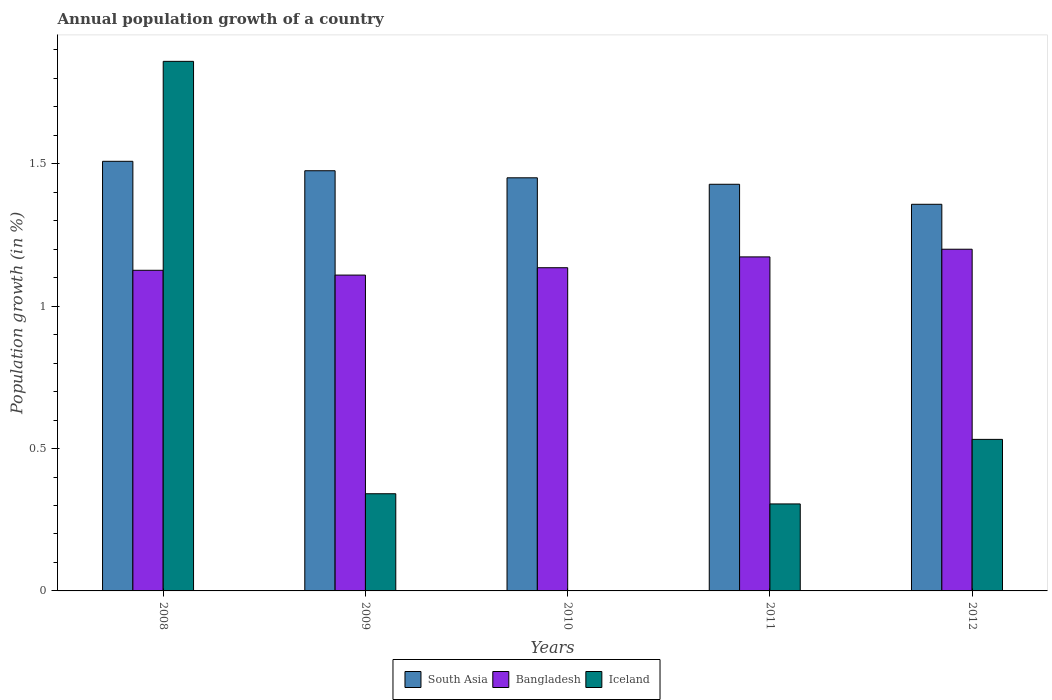How many different coloured bars are there?
Keep it short and to the point. 3. How many bars are there on the 1st tick from the left?
Offer a very short reply. 3. How many bars are there on the 1st tick from the right?
Your response must be concise. 3. What is the label of the 1st group of bars from the left?
Give a very brief answer. 2008. What is the annual population growth in Bangladesh in 2010?
Your answer should be very brief. 1.13. Across all years, what is the maximum annual population growth in Iceland?
Provide a succinct answer. 1.86. Across all years, what is the minimum annual population growth in South Asia?
Make the answer very short. 1.36. In which year was the annual population growth in Iceland maximum?
Ensure brevity in your answer.  2008. What is the total annual population growth in Iceland in the graph?
Make the answer very short. 3.04. What is the difference between the annual population growth in Iceland in 2008 and that in 2011?
Give a very brief answer. 1.55. What is the difference between the annual population growth in Bangladesh in 2010 and the annual population growth in South Asia in 2009?
Make the answer very short. -0.34. What is the average annual population growth in South Asia per year?
Ensure brevity in your answer.  1.44. In the year 2010, what is the difference between the annual population growth in Bangladesh and annual population growth in South Asia?
Offer a very short reply. -0.32. In how many years, is the annual population growth in Bangladesh greater than 1.1 %?
Give a very brief answer. 5. What is the ratio of the annual population growth in Bangladesh in 2008 to that in 2012?
Make the answer very short. 0.94. Is the annual population growth in South Asia in 2009 less than that in 2011?
Your response must be concise. No. What is the difference between the highest and the second highest annual population growth in Iceland?
Your answer should be very brief. 1.33. What is the difference between the highest and the lowest annual population growth in Bangladesh?
Ensure brevity in your answer.  0.09. Is the sum of the annual population growth in South Asia in 2008 and 2011 greater than the maximum annual population growth in Iceland across all years?
Keep it short and to the point. Yes. Is it the case that in every year, the sum of the annual population growth in Bangladesh and annual population growth in South Asia is greater than the annual population growth in Iceland?
Provide a succinct answer. Yes. Are all the bars in the graph horizontal?
Your answer should be very brief. No. How many years are there in the graph?
Provide a short and direct response. 5. Are the values on the major ticks of Y-axis written in scientific E-notation?
Your answer should be compact. No. Does the graph contain any zero values?
Your response must be concise. Yes. Where does the legend appear in the graph?
Provide a short and direct response. Bottom center. How many legend labels are there?
Your response must be concise. 3. How are the legend labels stacked?
Offer a very short reply. Horizontal. What is the title of the graph?
Your response must be concise. Annual population growth of a country. What is the label or title of the Y-axis?
Your response must be concise. Population growth (in %). What is the Population growth (in %) in South Asia in 2008?
Your response must be concise. 1.51. What is the Population growth (in %) in Bangladesh in 2008?
Provide a short and direct response. 1.13. What is the Population growth (in %) of Iceland in 2008?
Ensure brevity in your answer.  1.86. What is the Population growth (in %) of South Asia in 2009?
Your answer should be very brief. 1.48. What is the Population growth (in %) of Bangladesh in 2009?
Your response must be concise. 1.11. What is the Population growth (in %) of Iceland in 2009?
Provide a short and direct response. 0.34. What is the Population growth (in %) of South Asia in 2010?
Offer a terse response. 1.45. What is the Population growth (in %) of Bangladesh in 2010?
Your answer should be very brief. 1.13. What is the Population growth (in %) of Iceland in 2010?
Provide a short and direct response. 0. What is the Population growth (in %) in South Asia in 2011?
Keep it short and to the point. 1.43. What is the Population growth (in %) of Bangladesh in 2011?
Provide a succinct answer. 1.17. What is the Population growth (in %) in Iceland in 2011?
Your answer should be very brief. 0.31. What is the Population growth (in %) in South Asia in 2012?
Ensure brevity in your answer.  1.36. What is the Population growth (in %) in Bangladesh in 2012?
Give a very brief answer. 1.2. What is the Population growth (in %) in Iceland in 2012?
Offer a very short reply. 0.53. Across all years, what is the maximum Population growth (in %) in South Asia?
Provide a succinct answer. 1.51. Across all years, what is the maximum Population growth (in %) of Bangladesh?
Your answer should be compact. 1.2. Across all years, what is the maximum Population growth (in %) of Iceland?
Ensure brevity in your answer.  1.86. Across all years, what is the minimum Population growth (in %) in South Asia?
Give a very brief answer. 1.36. Across all years, what is the minimum Population growth (in %) of Bangladesh?
Offer a very short reply. 1.11. What is the total Population growth (in %) of South Asia in the graph?
Your answer should be compact. 7.22. What is the total Population growth (in %) in Bangladesh in the graph?
Keep it short and to the point. 5.74. What is the total Population growth (in %) in Iceland in the graph?
Keep it short and to the point. 3.04. What is the difference between the Population growth (in %) of South Asia in 2008 and that in 2009?
Ensure brevity in your answer.  0.03. What is the difference between the Population growth (in %) in Bangladesh in 2008 and that in 2009?
Provide a short and direct response. 0.02. What is the difference between the Population growth (in %) in Iceland in 2008 and that in 2009?
Make the answer very short. 1.52. What is the difference between the Population growth (in %) of South Asia in 2008 and that in 2010?
Offer a terse response. 0.06. What is the difference between the Population growth (in %) in Bangladesh in 2008 and that in 2010?
Your answer should be compact. -0.01. What is the difference between the Population growth (in %) in South Asia in 2008 and that in 2011?
Offer a terse response. 0.08. What is the difference between the Population growth (in %) in Bangladesh in 2008 and that in 2011?
Keep it short and to the point. -0.05. What is the difference between the Population growth (in %) of Iceland in 2008 and that in 2011?
Ensure brevity in your answer.  1.55. What is the difference between the Population growth (in %) in South Asia in 2008 and that in 2012?
Make the answer very short. 0.15. What is the difference between the Population growth (in %) in Bangladesh in 2008 and that in 2012?
Provide a short and direct response. -0.07. What is the difference between the Population growth (in %) of Iceland in 2008 and that in 2012?
Offer a terse response. 1.33. What is the difference between the Population growth (in %) of South Asia in 2009 and that in 2010?
Offer a very short reply. 0.02. What is the difference between the Population growth (in %) in Bangladesh in 2009 and that in 2010?
Give a very brief answer. -0.03. What is the difference between the Population growth (in %) of South Asia in 2009 and that in 2011?
Offer a terse response. 0.05. What is the difference between the Population growth (in %) in Bangladesh in 2009 and that in 2011?
Make the answer very short. -0.06. What is the difference between the Population growth (in %) in Iceland in 2009 and that in 2011?
Your answer should be very brief. 0.04. What is the difference between the Population growth (in %) in South Asia in 2009 and that in 2012?
Your answer should be very brief. 0.12. What is the difference between the Population growth (in %) in Bangladesh in 2009 and that in 2012?
Your response must be concise. -0.09. What is the difference between the Population growth (in %) of Iceland in 2009 and that in 2012?
Offer a terse response. -0.19. What is the difference between the Population growth (in %) of South Asia in 2010 and that in 2011?
Give a very brief answer. 0.02. What is the difference between the Population growth (in %) of Bangladesh in 2010 and that in 2011?
Provide a short and direct response. -0.04. What is the difference between the Population growth (in %) of South Asia in 2010 and that in 2012?
Offer a very short reply. 0.09. What is the difference between the Population growth (in %) in Bangladesh in 2010 and that in 2012?
Provide a short and direct response. -0.07. What is the difference between the Population growth (in %) in South Asia in 2011 and that in 2012?
Make the answer very short. 0.07. What is the difference between the Population growth (in %) in Bangladesh in 2011 and that in 2012?
Provide a short and direct response. -0.03. What is the difference between the Population growth (in %) in Iceland in 2011 and that in 2012?
Give a very brief answer. -0.23. What is the difference between the Population growth (in %) in South Asia in 2008 and the Population growth (in %) in Bangladesh in 2009?
Offer a terse response. 0.4. What is the difference between the Population growth (in %) in South Asia in 2008 and the Population growth (in %) in Iceland in 2009?
Keep it short and to the point. 1.17. What is the difference between the Population growth (in %) in Bangladesh in 2008 and the Population growth (in %) in Iceland in 2009?
Keep it short and to the point. 0.78. What is the difference between the Population growth (in %) in South Asia in 2008 and the Population growth (in %) in Bangladesh in 2010?
Ensure brevity in your answer.  0.37. What is the difference between the Population growth (in %) in South Asia in 2008 and the Population growth (in %) in Bangladesh in 2011?
Provide a short and direct response. 0.34. What is the difference between the Population growth (in %) of South Asia in 2008 and the Population growth (in %) of Iceland in 2011?
Offer a very short reply. 1.2. What is the difference between the Population growth (in %) in Bangladesh in 2008 and the Population growth (in %) in Iceland in 2011?
Your answer should be compact. 0.82. What is the difference between the Population growth (in %) in South Asia in 2008 and the Population growth (in %) in Bangladesh in 2012?
Your answer should be very brief. 0.31. What is the difference between the Population growth (in %) in South Asia in 2008 and the Population growth (in %) in Iceland in 2012?
Provide a short and direct response. 0.98. What is the difference between the Population growth (in %) of Bangladesh in 2008 and the Population growth (in %) of Iceland in 2012?
Make the answer very short. 0.59. What is the difference between the Population growth (in %) in South Asia in 2009 and the Population growth (in %) in Bangladesh in 2010?
Give a very brief answer. 0.34. What is the difference between the Population growth (in %) of South Asia in 2009 and the Population growth (in %) of Bangladesh in 2011?
Your answer should be compact. 0.3. What is the difference between the Population growth (in %) in South Asia in 2009 and the Population growth (in %) in Iceland in 2011?
Your answer should be very brief. 1.17. What is the difference between the Population growth (in %) in Bangladesh in 2009 and the Population growth (in %) in Iceland in 2011?
Your answer should be compact. 0.8. What is the difference between the Population growth (in %) of South Asia in 2009 and the Population growth (in %) of Bangladesh in 2012?
Your answer should be compact. 0.28. What is the difference between the Population growth (in %) of South Asia in 2009 and the Population growth (in %) of Iceland in 2012?
Your response must be concise. 0.94. What is the difference between the Population growth (in %) in Bangladesh in 2009 and the Population growth (in %) in Iceland in 2012?
Make the answer very short. 0.58. What is the difference between the Population growth (in %) in South Asia in 2010 and the Population growth (in %) in Bangladesh in 2011?
Your answer should be very brief. 0.28. What is the difference between the Population growth (in %) of South Asia in 2010 and the Population growth (in %) of Iceland in 2011?
Your response must be concise. 1.15. What is the difference between the Population growth (in %) of Bangladesh in 2010 and the Population growth (in %) of Iceland in 2011?
Offer a very short reply. 0.83. What is the difference between the Population growth (in %) in South Asia in 2010 and the Population growth (in %) in Bangladesh in 2012?
Offer a very short reply. 0.25. What is the difference between the Population growth (in %) of South Asia in 2010 and the Population growth (in %) of Iceland in 2012?
Give a very brief answer. 0.92. What is the difference between the Population growth (in %) in Bangladesh in 2010 and the Population growth (in %) in Iceland in 2012?
Your answer should be very brief. 0.6. What is the difference between the Population growth (in %) in South Asia in 2011 and the Population growth (in %) in Bangladesh in 2012?
Your answer should be compact. 0.23. What is the difference between the Population growth (in %) of South Asia in 2011 and the Population growth (in %) of Iceland in 2012?
Make the answer very short. 0.9. What is the difference between the Population growth (in %) of Bangladesh in 2011 and the Population growth (in %) of Iceland in 2012?
Ensure brevity in your answer.  0.64. What is the average Population growth (in %) in South Asia per year?
Your response must be concise. 1.44. What is the average Population growth (in %) in Bangladesh per year?
Keep it short and to the point. 1.15. What is the average Population growth (in %) of Iceland per year?
Offer a very short reply. 0.61. In the year 2008, what is the difference between the Population growth (in %) of South Asia and Population growth (in %) of Bangladesh?
Your answer should be very brief. 0.38. In the year 2008, what is the difference between the Population growth (in %) in South Asia and Population growth (in %) in Iceland?
Provide a succinct answer. -0.35. In the year 2008, what is the difference between the Population growth (in %) of Bangladesh and Population growth (in %) of Iceland?
Provide a succinct answer. -0.73. In the year 2009, what is the difference between the Population growth (in %) of South Asia and Population growth (in %) of Bangladesh?
Your response must be concise. 0.37. In the year 2009, what is the difference between the Population growth (in %) of South Asia and Population growth (in %) of Iceland?
Keep it short and to the point. 1.13. In the year 2009, what is the difference between the Population growth (in %) in Bangladesh and Population growth (in %) in Iceland?
Give a very brief answer. 0.77. In the year 2010, what is the difference between the Population growth (in %) of South Asia and Population growth (in %) of Bangladesh?
Make the answer very short. 0.32. In the year 2011, what is the difference between the Population growth (in %) of South Asia and Population growth (in %) of Bangladesh?
Give a very brief answer. 0.26. In the year 2011, what is the difference between the Population growth (in %) of South Asia and Population growth (in %) of Iceland?
Give a very brief answer. 1.12. In the year 2011, what is the difference between the Population growth (in %) of Bangladesh and Population growth (in %) of Iceland?
Keep it short and to the point. 0.87. In the year 2012, what is the difference between the Population growth (in %) in South Asia and Population growth (in %) in Bangladesh?
Keep it short and to the point. 0.16. In the year 2012, what is the difference between the Population growth (in %) of South Asia and Population growth (in %) of Iceland?
Your response must be concise. 0.83. In the year 2012, what is the difference between the Population growth (in %) in Bangladesh and Population growth (in %) in Iceland?
Make the answer very short. 0.67. What is the ratio of the Population growth (in %) of South Asia in 2008 to that in 2009?
Give a very brief answer. 1.02. What is the ratio of the Population growth (in %) of Bangladesh in 2008 to that in 2009?
Provide a succinct answer. 1.02. What is the ratio of the Population growth (in %) of Iceland in 2008 to that in 2009?
Provide a succinct answer. 5.45. What is the ratio of the Population growth (in %) of South Asia in 2008 to that in 2010?
Provide a succinct answer. 1.04. What is the ratio of the Population growth (in %) of South Asia in 2008 to that in 2011?
Offer a very short reply. 1.06. What is the ratio of the Population growth (in %) in Bangladesh in 2008 to that in 2011?
Offer a very short reply. 0.96. What is the ratio of the Population growth (in %) in Iceland in 2008 to that in 2011?
Provide a short and direct response. 6.09. What is the ratio of the Population growth (in %) of South Asia in 2008 to that in 2012?
Give a very brief answer. 1.11. What is the ratio of the Population growth (in %) in Bangladesh in 2008 to that in 2012?
Make the answer very short. 0.94. What is the ratio of the Population growth (in %) in Iceland in 2008 to that in 2012?
Offer a very short reply. 3.49. What is the ratio of the Population growth (in %) in South Asia in 2009 to that in 2010?
Your response must be concise. 1.02. What is the ratio of the Population growth (in %) in Bangladesh in 2009 to that in 2010?
Give a very brief answer. 0.98. What is the ratio of the Population growth (in %) in Bangladesh in 2009 to that in 2011?
Keep it short and to the point. 0.95. What is the ratio of the Population growth (in %) of Iceland in 2009 to that in 2011?
Provide a short and direct response. 1.12. What is the ratio of the Population growth (in %) of South Asia in 2009 to that in 2012?
Offer a terse response. 1.09. What is the ratio of the Population growth (in %) of Bangladesh in 2009 to that in 2012?
Offer a terse response. 0.92. What is the ratio of the Population growth (in %) in Iceland in 2009 to that in 2012?
Your response must be concise. 0.64. What is the ratio of the Population growth (in %) of South Asia in 2010 to that in 2011?
Your response must be concise. 1.02. What is the ratio of the Population growth (in %) of Bangladesh in 2010 to that in 2011?
Keep it short and to the point. 0.97. What is the ratio of the Population growth (in %) of South Asia in 2010 to that in 2012?
Your answer should be very brief. 1.07. What is the ratio of the Population growth (in %) of Bangladesh in 2010 to that in 2012?
Ensure brevity in your answer.  0.95. What is the ratio of the Population growth (in %) of South Asia in 2011 to that in 2012?
Make the answer very short. 1.05. What is the ratio of the Population growth (in %) in Bangladesh in 2011 to that in 2012?
Offer a terse response. 0.98. What is the ratio of the Population growth (in %) of Iceland in 2011 to that in 2012?
Keep it short and to the point. 0.57. What is the difference between the highest and the second highest Population growth (in %) in South Asia?
Offer a very short reply. 0.03. What is the difference between the highest and the second highest Population growth (in %) in Bangladesh?
Offer a terse response. 0.03. What is the difference between the highest and the second highest Population growth (in %) of Iceland?
Make the answer very short. 1.33. What is the difference between the highest and the lowest Population growth (in %) of South Asia?
Make the answer very short. 0.15. What is the difference between the highest and the lowest Population growth (in %) in Bangladesh?
Provide a succinct answer. 0.09. What is the difference between the highest and the lowest Population growth (in %) in Iceland?
Your answer should be compact. 1.86. 